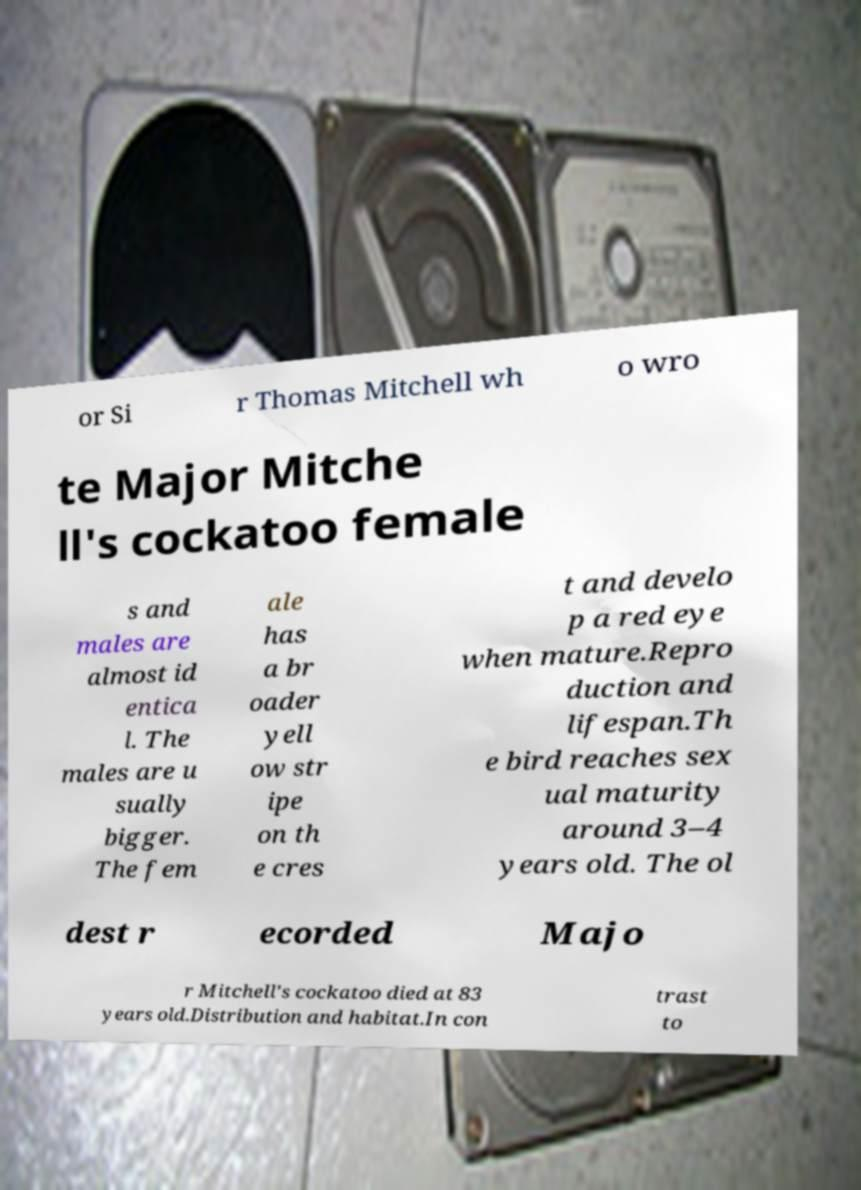Can you accurately transcribe the text from the provided image for me? or Si r Thomas Mitchell wh o wro te Major Mitche ll's cockatoo female s and males are almost id entica l. The males are u sually bigger. The fem ale has a br oader yell ow str ipe on th e cres t and develo p a red eye when mature.Repro duction and lifespan.Th e bird reaches sex ual maturity around 3–4 years old. The ol dest r ecorded Majo r Mitchell's cockatoo died at 83 years old.Distribution and habitat.In con trast to 